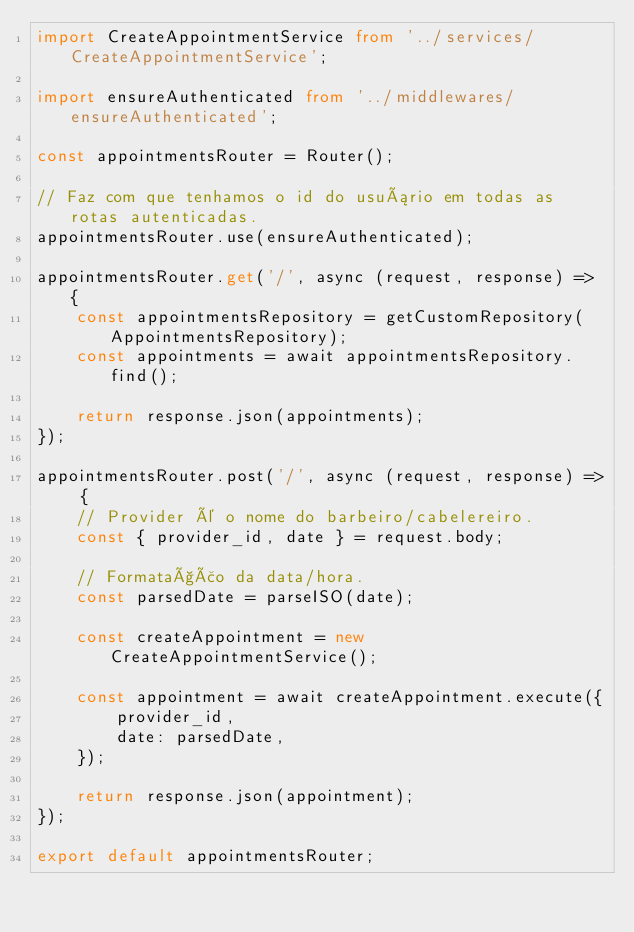Convert code to text. <code><loc_0><loc_0><loc_500><loc_500><_TypeScript_>import CreateAppointmentService from '../services/CreateAppointmentService';

import ensureAuthenticated from '../middlewares/ensureAuthenticated';

const appointmentsRouter = Router();

// Faz com que tenhamos o id do usuário em todas as rotas autenticadas.
appointmentsRouter.use(ensureAuthenticated);

appointmentsRouter.get('/', async (request, response) => {
    const appointmentsRepository = getCustomRepository(AppointmentsRepository);
    const appointments = await appointmentsRepository.find();

    return response.json(appointments);
});

appointmentsRouter.post('/', async (request, response) => {
    // Provider é o nome do barbeiro/cabelereiro.
    const { provider_id, date } = request.body;

    // Formatação da data/hora.
    const parsedDate = parseISO(date);

    const createAppointment = new CreateAppointmentService();

    const appointment = await createAppointment.execute({
        provider_id,
        date: parsedDate,
    });

    return response.json(appointment);
});

export default appointmentsRouter;
</code> 